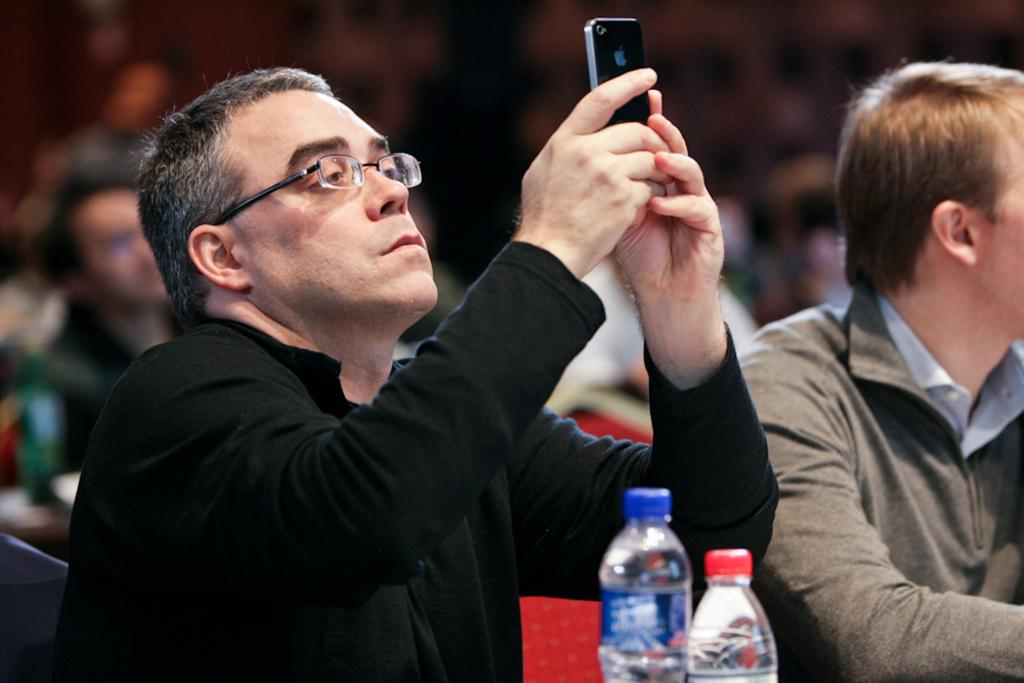What is the man in the image doing with the mobile? The man is holding a mobile and taking a picture. What are the other men in the image doing? The other men are seated in the image. How many water bottles are visible in the image? There are two water bottles in the image. What is a unique position of some people in the image? Some people are seated on their backs in the image. What type of powder is being used for the plantation in the image? There is no plantation or powder present in the image. What sport are the people playing in the image? There is no sport being played in the image; the people are seated or taking a picture. 